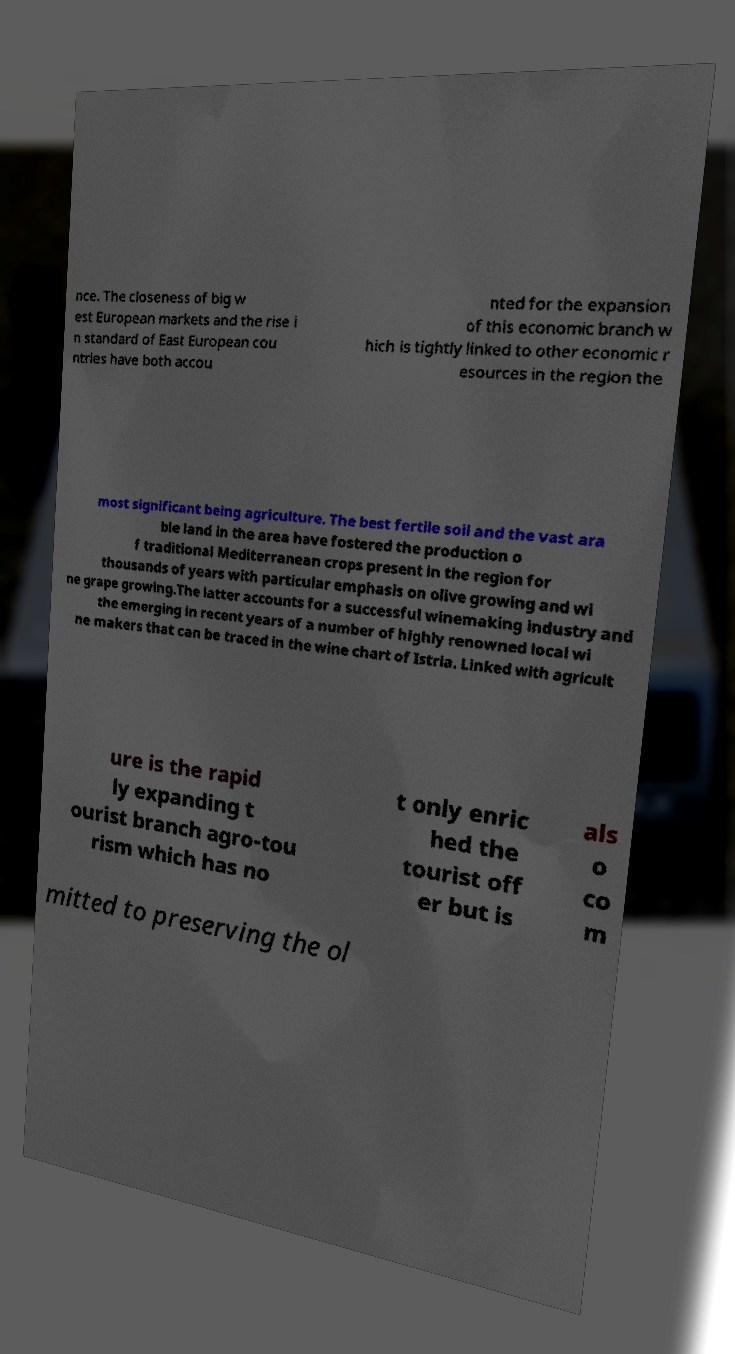Can you read and provide the text displayed in the image?This photo seems to have some interesting text. Can you extract and type it out for me? nce. The closeness of big w est European markets and the rise i n standard of East European cou ntries have both accou nted for the expansion of this economic branch w hich is tightly linked to other economic r esources in the region the most significant being agriculture. The best fertile soil and the vast ara ble land in the area have fostered the production o f traditional Mediterranean crops present in the region for thousands of years with particular emphasis on olive growing and wi ne grape growing.The latter accounts for a successful winemaking industry and the emerging in recent years of a number of highly renowned local wi ne makers that can be traced in the wine chart of Istria. Linked with agricult ure is the rapid ly expanding t ourist branch agro-tou rism which has no t only enric hed the tourist off er but is als o co m mitted to preserving the ol 